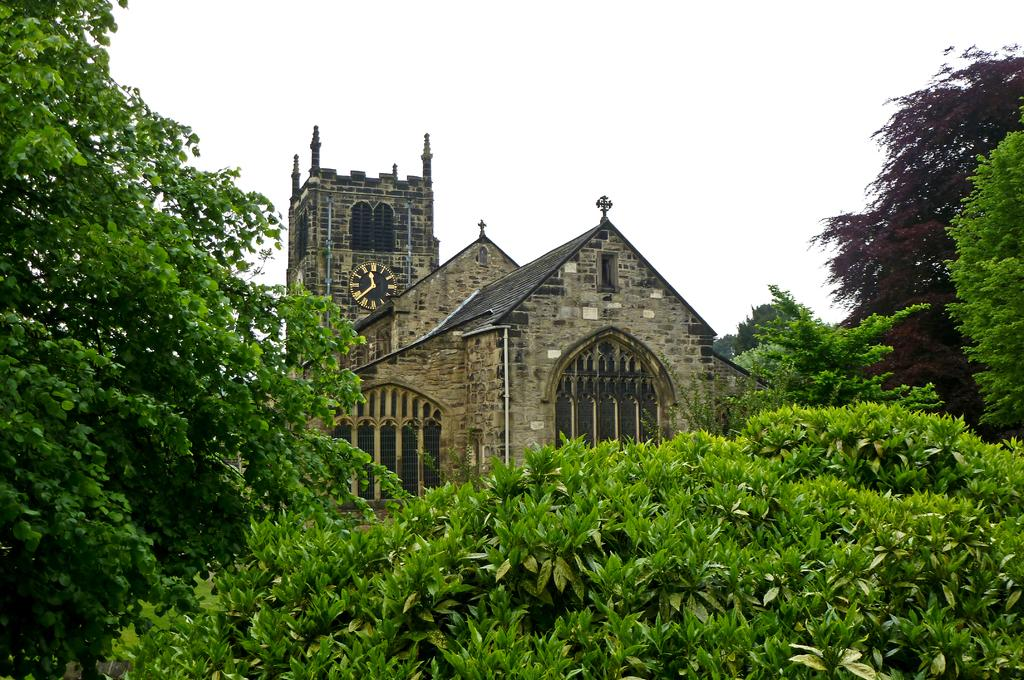What is the main structure in the center of the image? There is a house in the center of the image. What feature can be seen on the house? There is a clock on the house. What type of vegetation is present in the image? There is greenery in the image. What is visible at the top of the image? The sky is visible at the top of the image. What type of face can be seen on the zinc in the image? There is no zinc or face present in the image. What day is depicted in the image? The image does not depict a specific day; it is a static representation of a house, clock, greenery, and sky. 